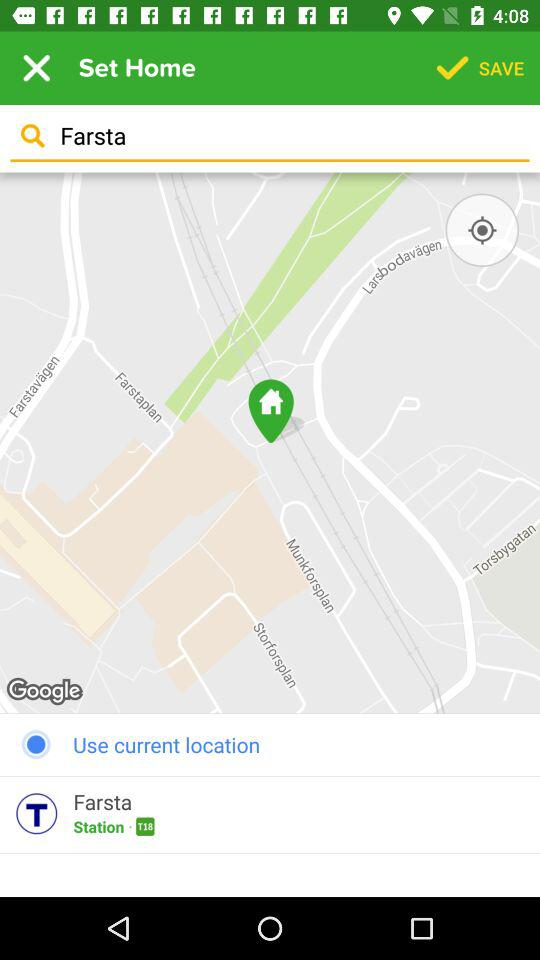What's the selected location? The selected location is Farsta. 